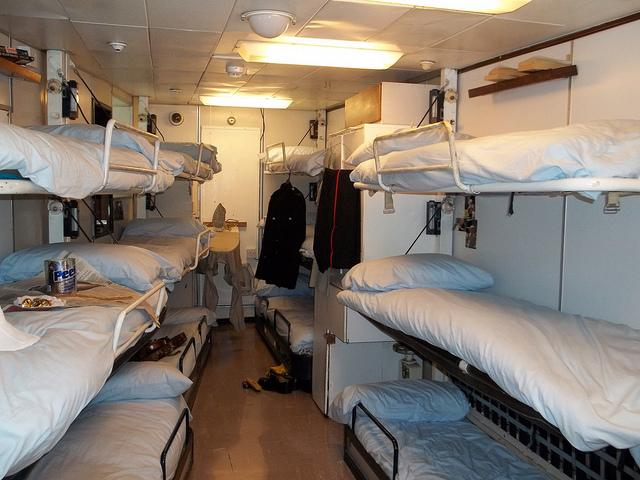Who likely resides here? workers 